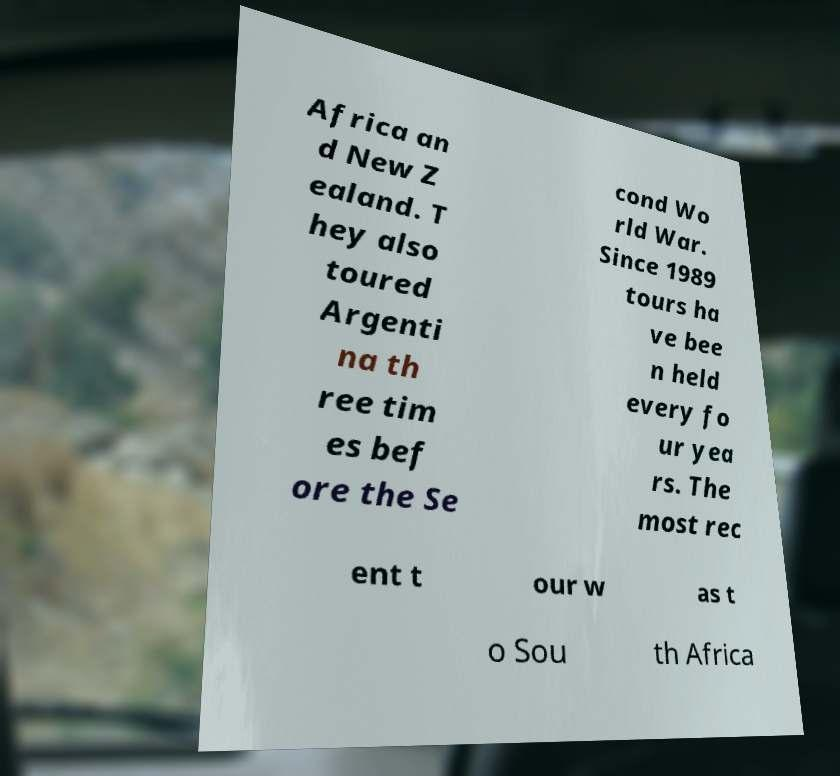Could you extract and type out the text from this image? Africa an d New Z ealand. T hey also toured Argenti na th ree tim es bef ore the Se cond Wo rld War. Since 1989 tours ha ve bee n held every fo ur yea rs. The most rec ent t our w as t o Sou th Africa 